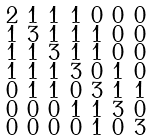<formula> <loc_0><loc_0><loc_500><loc_500>\begin{smallmatrix} 2 & 1 & 1 & 1 & 0 & 0 & 0 \\ 1 & 3 & 1 & 1 & 1 & 0 & 0 \\ 1 & 1 & 3 & 1 & 1 & 0 & 0 \\ 1 & 1 & 1 & 3 & 0 & 1 & 0 \\ 0 & 1 & 1 & 0 & 3 & 1 & 1 \\ 0 & 0 & 0 & 1 & 1 & 3 & 0 \\ 0 & 0 & 0 & 0 & 1 & 0 & 3 \end{smallmatrix}</formula> 